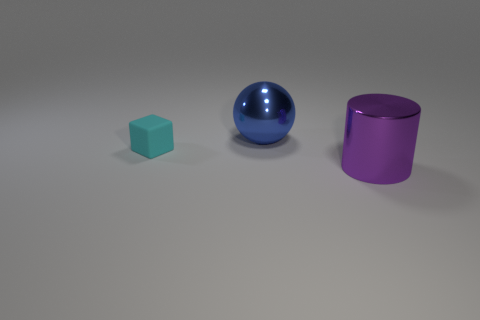Is there anything else that has the same size as the cyan matte thing?
Keep it short and to the point. No. What number of purple things are either matte cubes or big metallic spheres?
Make the answer very short. 0. Is the shape of the cyan matte thing the same as the large metallic thing that is in front of the ball?
Provide a short and direct response. No. What is the shape of the large purple thing?
Offer a terse response. Cylinder. There is a blue sphere that is the same size as the cylinder; what material is it?
Your answer should be very brief. Metal. How many things are shiny balls or big shiny things that are on the left side of the purple cylinder?
Provide a short and direct response. 1. There is a sphere that is made of the same material as the purple object; what size is it?
Offer a very short reply. Large. The thing left of the thing behind the cyan object is what shape?
Keep it short and to the point. Cube. There is a object that is both to the left of the purple metallic thing and to the right of the small matte cube; what size is it?
Your answer should be very brief. Large. Is there a tiny green matte object of the same shape as the purple metallic thing?
Make the answer very short. No. 